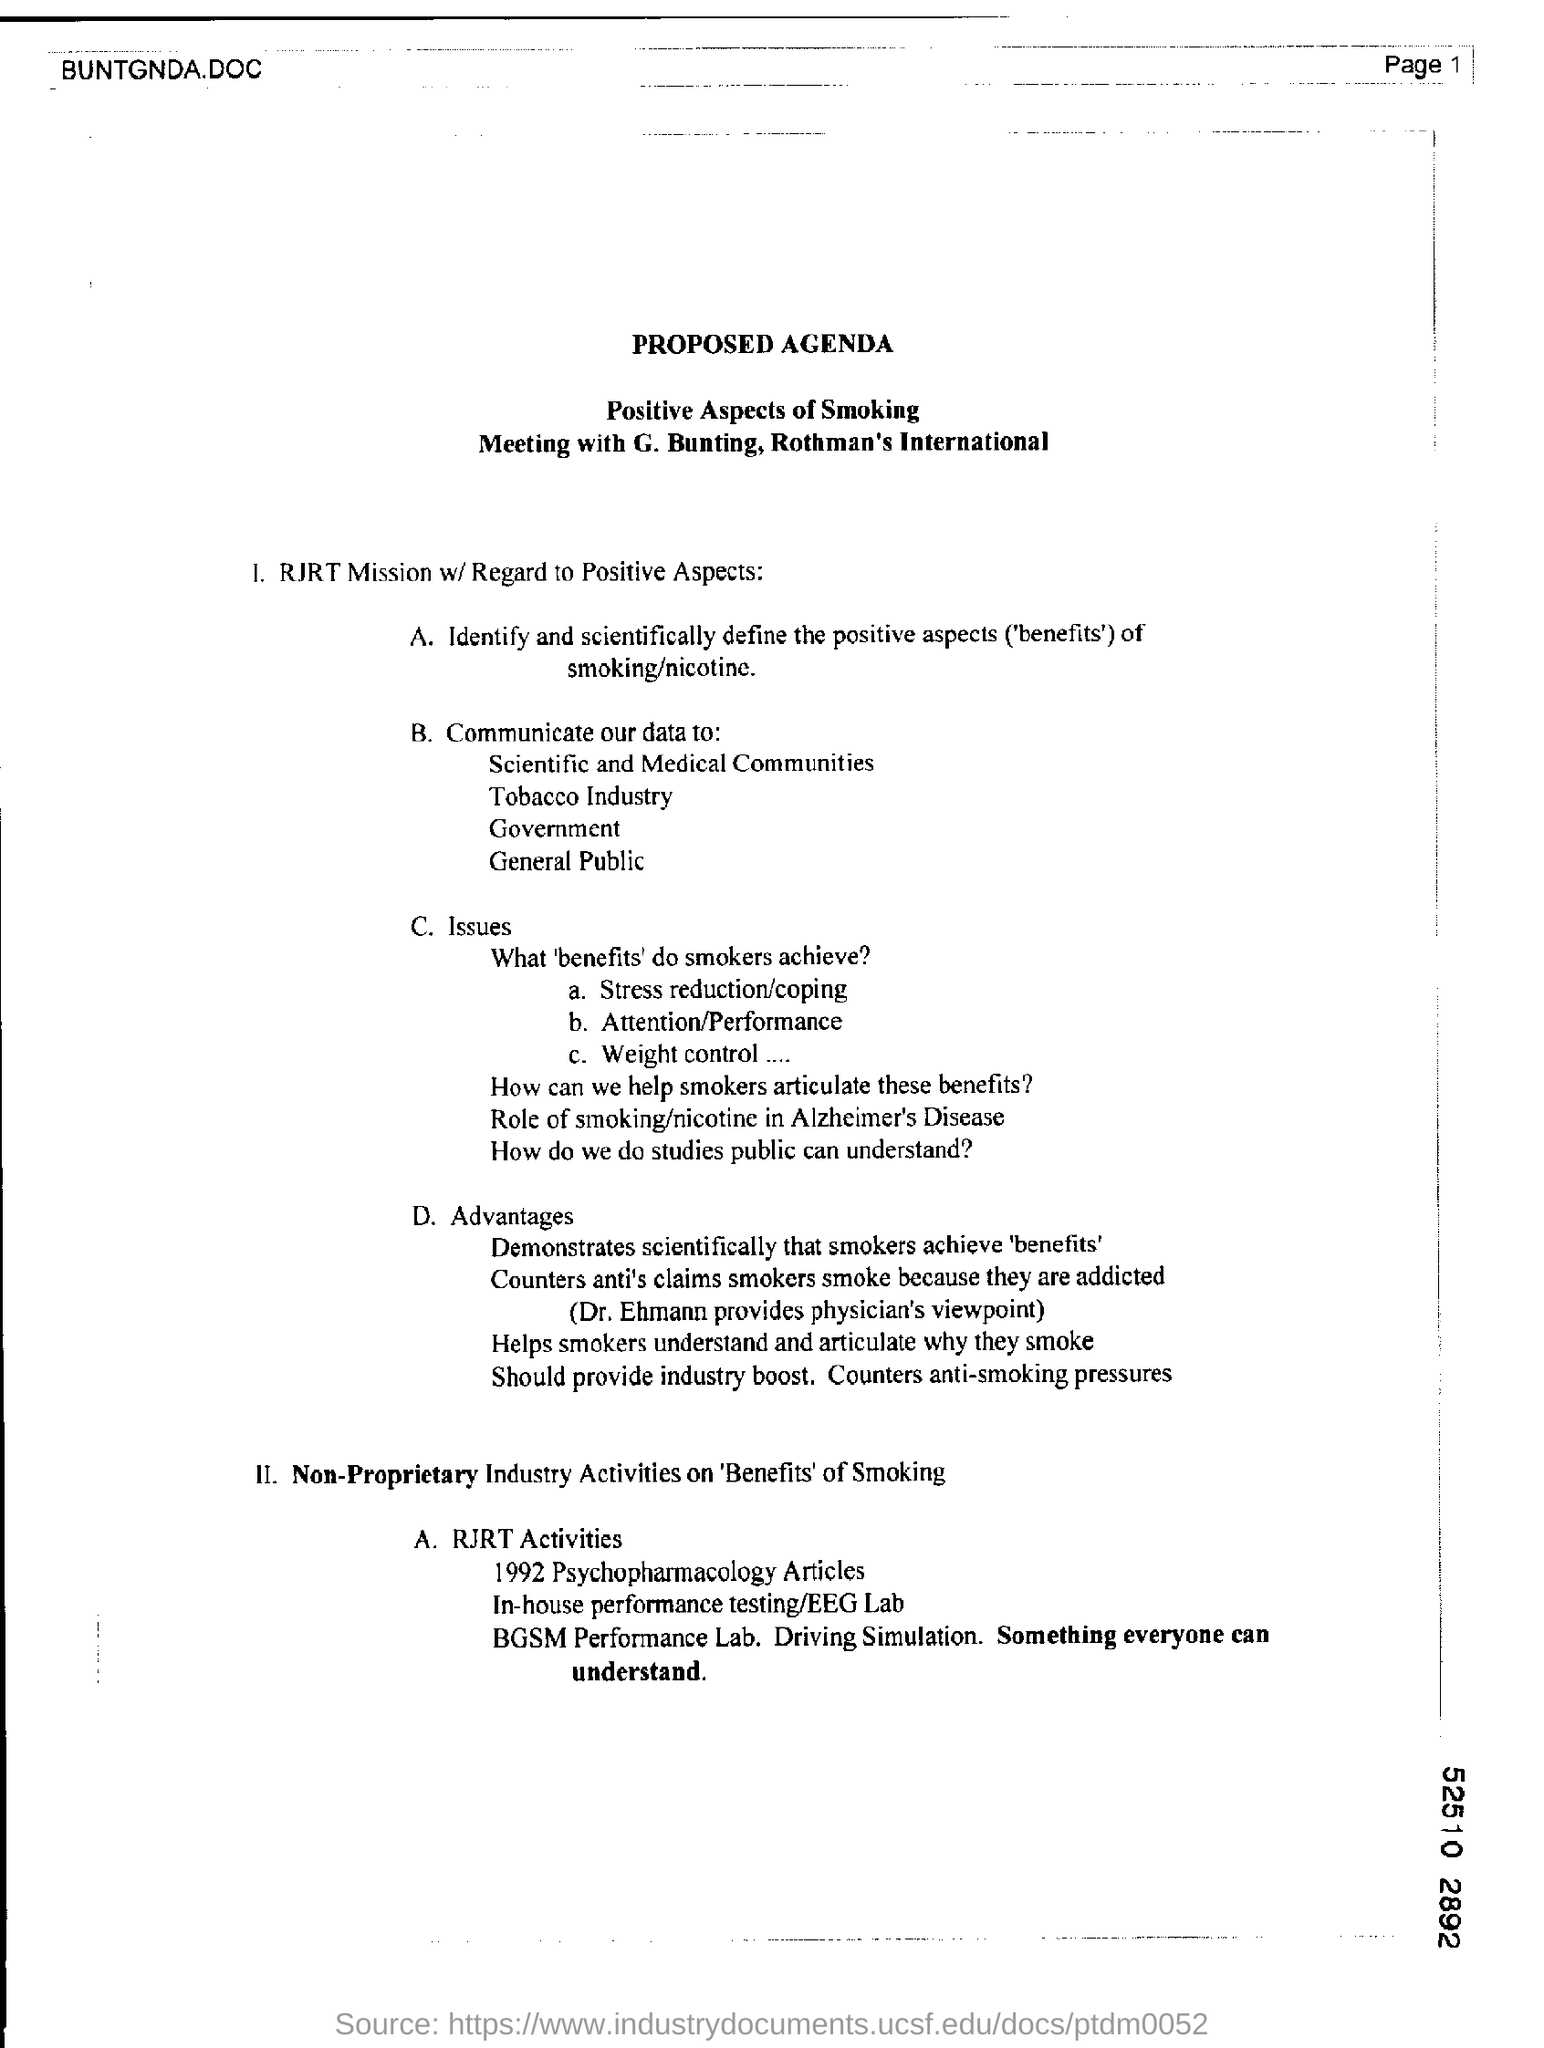Mention the page number at top right corner of the page ?
Give a very brief answer. 1. What is the heading at top of the page ?
Give a very brief answer. Proposed agenda. 